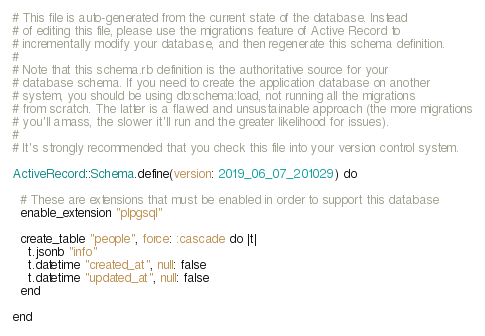<code> <loc_0><loc_0><loc_500><loc_500><_Ruby_># This file is auto-generated from the current state of the database. Instead
# of editing this file, please use the migrations feature of Active Record to
# incrementally modify your database, and then regenerate this schema definition.
#
# Note that this schema.rb definition is the authoritative source for your
# database schema. If you need to create the application database on another
# system, you should be using db:schema:load, not running all the migrations
# from scratch. The latter is a flawed and unsustainable approach (the more migrations
# you'll amass, the slower it'll run and the greater likelihood for issues).
#
# It's strongly recommended that you check this file into your version control system.

ActiveRecord::Schema.define(version: 2019_06_07_201029) do

  # These are extensions that must be enabled in order to support this database
  enable_extension "plpgsql"

  create_table "people", force: :cascade do |t|
    t.jsonb "info"
    t.datetime "created_at", null: false
    t.datetime "updated_at", null: false
  end

end
</code> 